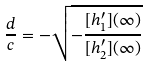<formula> <loc_0><loc_0><loc_500><loc_500>\frac { d } { c } = - \sqrt { - \frac { [ h ^ { \prime } _ { 1 } ] ( \infty ) } { [ h ^ { \prime } _ { 2 } ] ( \infty ) } }</formula> 